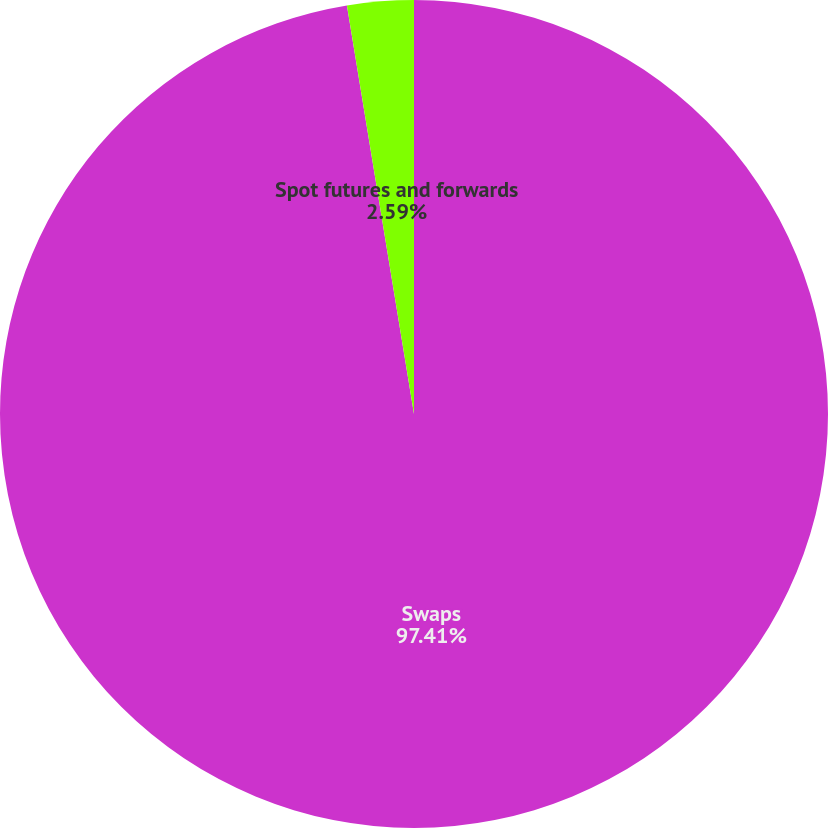Convert chart. <chart><loc_0><loc_0><loc_500><loc_500><pie_chart><fcel>Swaps<fcel>Spot futures and forwards<nl><fcel>97.41%<fcel>2.59%<nl></chart> 